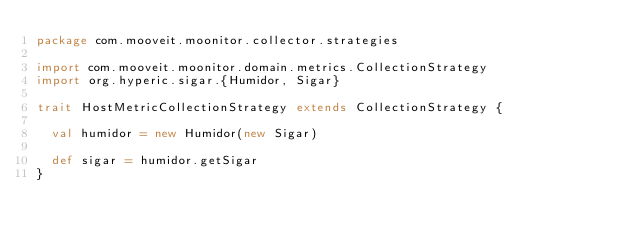<code> <loc_0><loc_0><loc_500><loc_500><_Scala_>package com.mooveit.moonitor.collector.strategies

import com.mooveit.moonitor.domain.metrics.CollectionStrategy
import org.hyperic.sigar.{Humidor, Sigar}

trait HostMetricCollectionStrategy extends CollectionStrategy {

  val humidor = new Humidor(new Sigar)

  def sigar = humidor.getSigar
}
</code> 